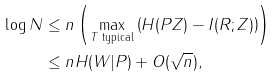<formula> <loc_0><loc_0><loc_500><loc_500>\log N & \leq n \left ( \max _ { T \text { typical} } \left ( H ( P Z ) - I ( R ; Z ) \right ) \right ) \\ & \leq n H ( W | P ) + O ( \sqrt { n } ) ,</formula> 